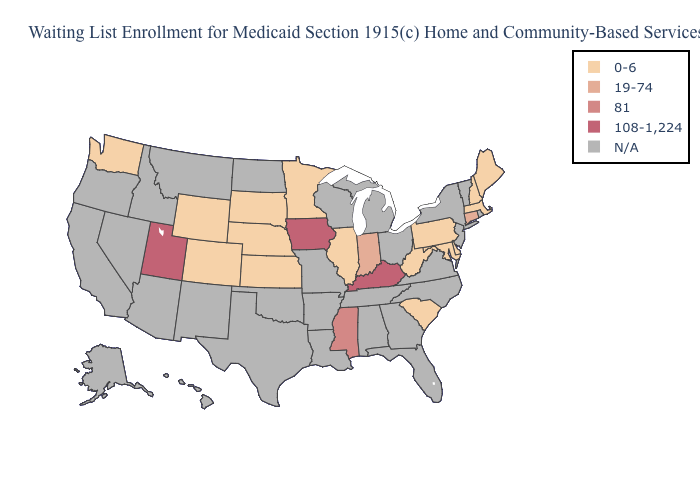How many symbols are there in the legend?
Quick response, please. 5. Among the states that border Tennessee , which have the lowest value?
Be succinct. Mississippi. What is the value of Michigan?
Answer briefly. N/A. Does Kentucky have the highest value in the USA?
Give a very brief answer. Yes. Does Connecticut have the highest value in the USA?
Write a very short answer. No. Name the states that have a value in the range N/A?
Keep it brief. Alabama, Alaska, Arizona, Arkansas, California, Florida, Georgia, Hawaii, Idaho, Louisiana, Michigan, Missouri, Montana, Nevada, New Jersey, New Mexico, New York, North Carolina, North Dakota, Ohio, Oklahoma, Oregon, Rhode Island, Tennessee, Texas, Vermont, Virginia, Wisconsin. Does Wyoming have the lowest value in the USA?
Short answer required. Yes. Which states have the lowest value in the USA?
Write a very short answer. Colorado, Delaware, Illinois, Kansas, Maine, Maryland, Massachusetts, Minnesota, Nebraska, New Hampshire, Pennsylvania, South Carolina, South Dakota, Washington, West Virginia, Wyoming. Name the states that have a value in the range N/A?
Keep it brief. Alabama, Alaska, Arizona, Arkansas, California, Florida, Georgia, Hawaii, Idaho, Louisiana, Michigan, Missouri, Montana, Nevada, New Jersey, New Mexico, New York, North Carolina, North Dakota, Ohio, Oklahoma, Oregon, Rhode Island, Tennessee, Texas, Vermont, Virginia, Wisconsin. Name the states that have a value in the range 81?
Short answer required. Mississippi. Does Utah have the lowest value in the USA?
Quick response, please. No. Is the legend a continuous bar?
Write a very short answer. No. Does Mississippi have the lowest value in the USA?
Short answer required. No. Does Washington have the highest value in the West?
Quick response, please. No. What is the value of Utah?
Short answer required. 108-1,224. 